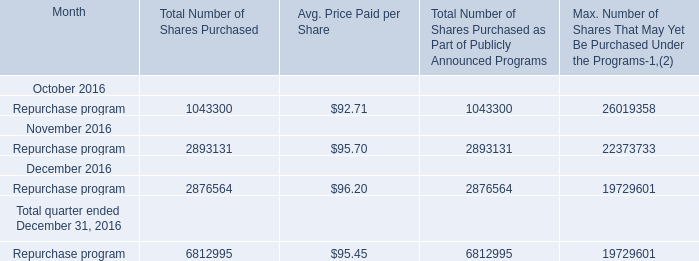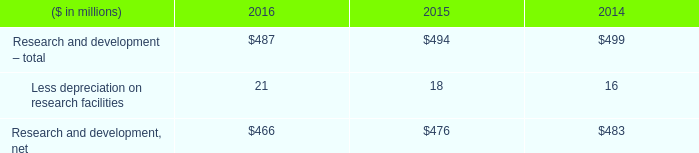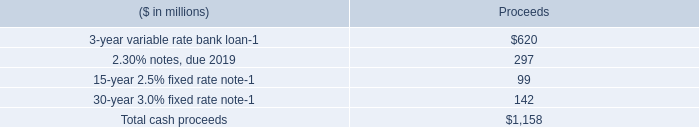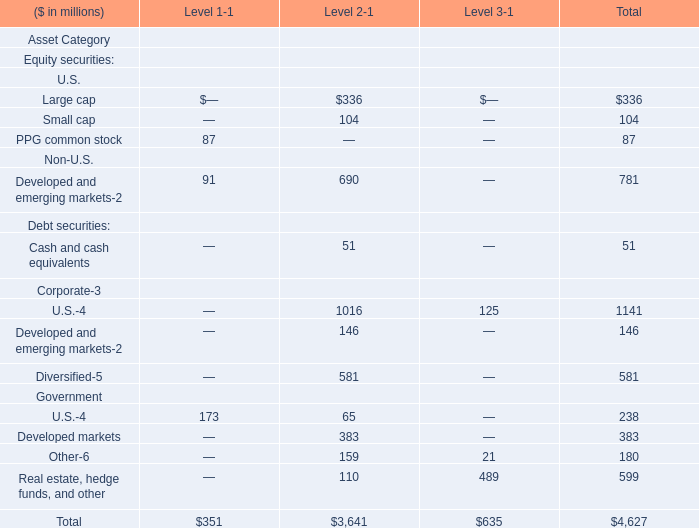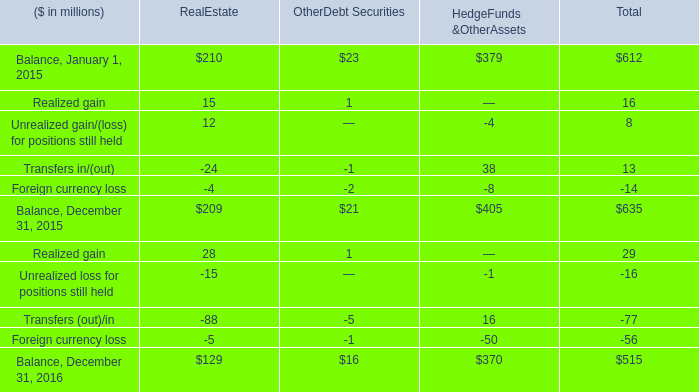What was the average value of the Foreign currency loss in the year where Balance, January 1, 2015 is positive? (in million) 
Answer: -14.0. 